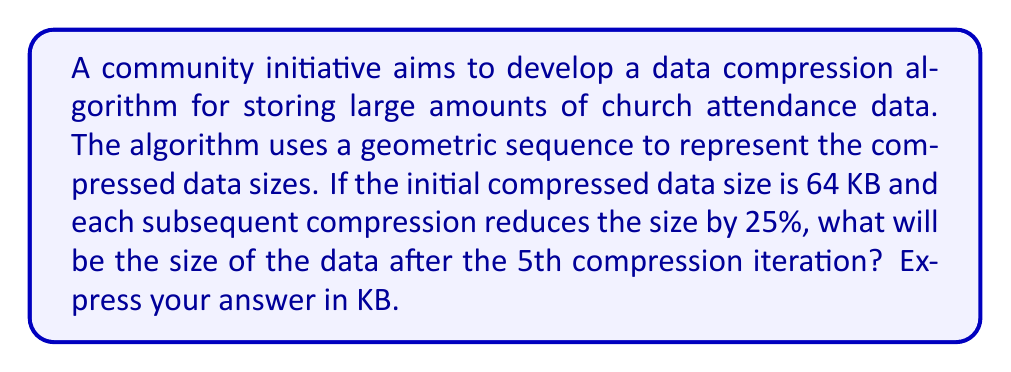Can you answer this question? Let's approach this step-by-step:

1) In a geometric sequence, each term is a constant multiple of the previous term. In this case, each compression reduces the size by 25%, meaning it keeps 75% of the previous size.

2) We can represent this as a geometric sequence with:
   - Initial term: $a_1 = 64$ KB
   - Common ratio: $r = 0.75$ (75% or 1 - 25%)

3) The general term of a geometric sequence is given by:
   $$a_n = a_1 \cdot r^{n-1}$$

4) We want to find the 5th term, so $n = 5$:
   $$a_5 = 64 \cdot 0.75^{5-1} = 64 \cdot 0.75^4$$

5) Let's calculate this:
   $$\begin{align}
   a_5 &= 64 \cdot 0.75^4 \\
       &= 64 \cdot 0.3164062500 \\
       &= 20.25 \text{ KB}
   \end{align}$$

6) Rounding to two decimal places:
   $$a_5 \approx 20.25 \text{ KB}$$
Answer: 20.25 KB 